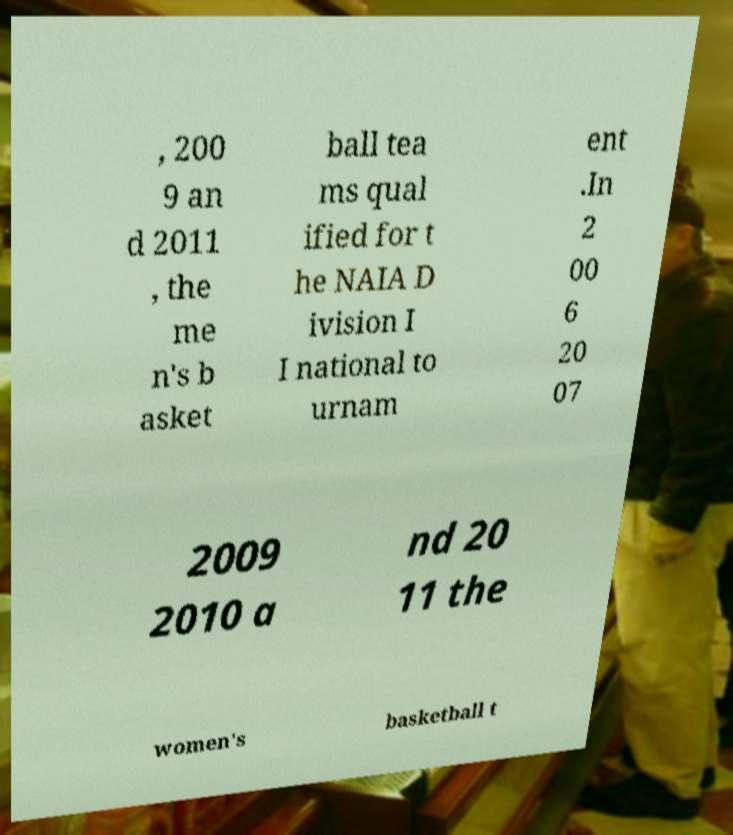Please read and relay the text visible in this image. What does it say? , 200 9 an d 2011 , the me n's b asket ball tea ms qual ified for t he NAIA D ivision I I national to urnam ent .In 2 00 6 20 07 2009 2010 a nd 20 11 the women's basketball t 